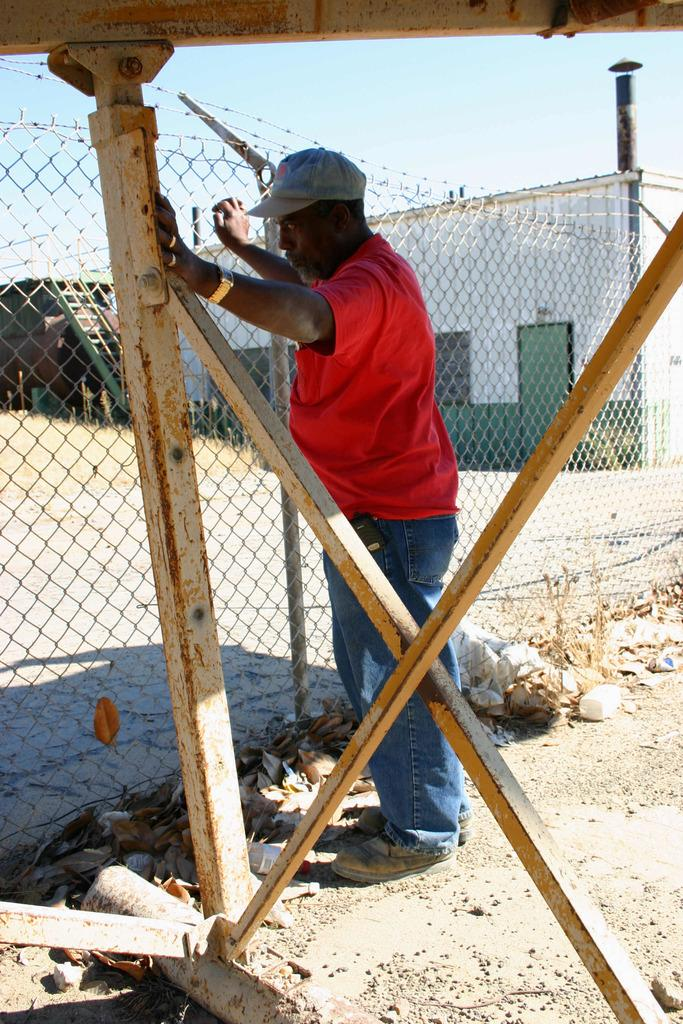What is the person in the image doing? The person is standing in the image. What is the person wearing? The person is wearing a red and red and blue color dress. What type of fencing can be seen in the image? There is net fencing in the image. What objects are visible in the image? There are objects visible in the image, but their specific nature is not mentioned in the facts. What type of poles are present in the image? There are iron poles in the image. What type of structures can be seen in the image? There are houses in the image. What type of crook can be seen in the image? There is no crook present in the image. What type of church can be seen in the image? There is no church present in the image. 